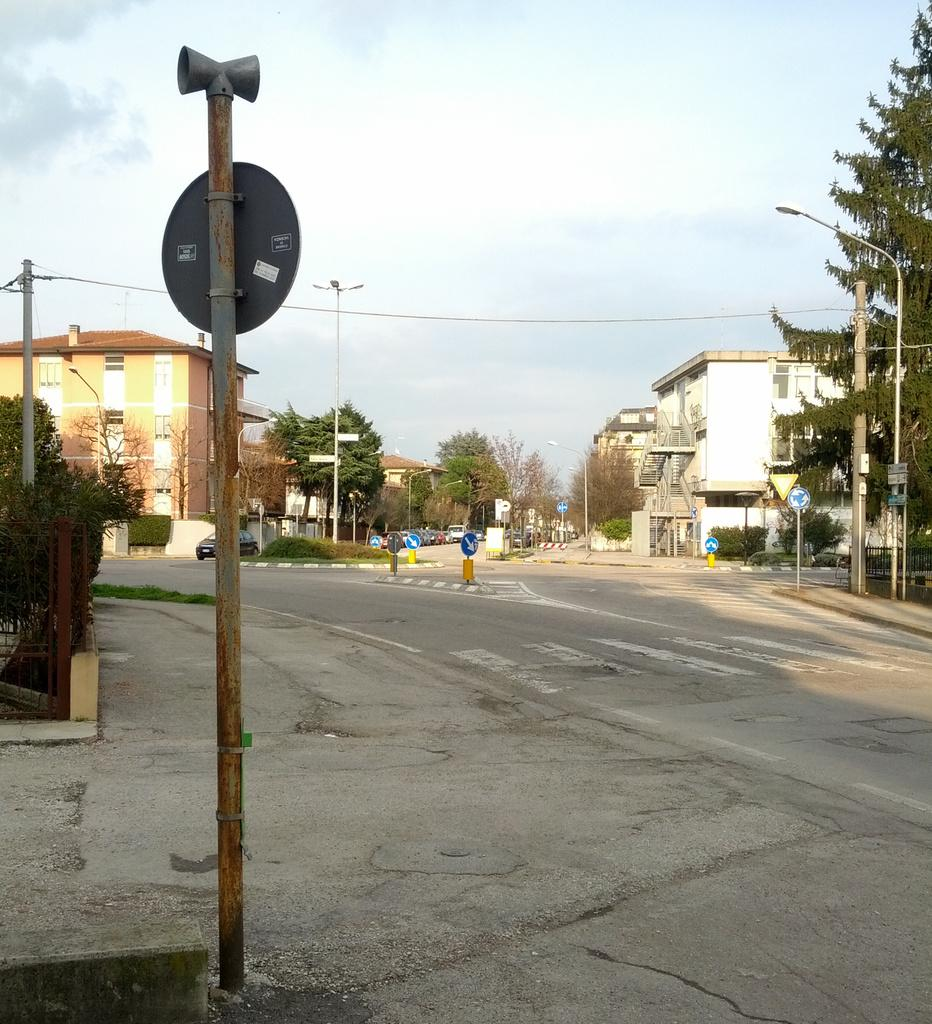What type of street is depicted in the image? There is a 4-way street in the image. What can be seen around the street? There are houses surrounding the street. What type of vegetation is present in the image? There are trees in the image. What structures can be seen in the image? There are poles in the image. What month is displayed on the calendar in the image? There is no calendar present in the image, so it is not possible to determine the month. 